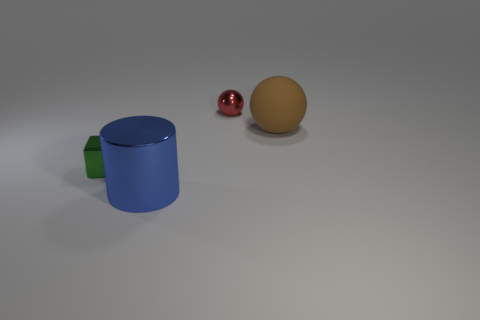Add 4 balls. How many objects exist? 8 Subtract all cubes. How many objects are left? 3 Subtract all metal balls. Subtract all big brown things. How many objects are left? 2 Add 3 red shiny balls. How many red shiny balls are left? 4 Add 4 small shiny objects. How many small shiny objects exist? 6 Subtract 0 purple blocks. How many objects are left? 4 